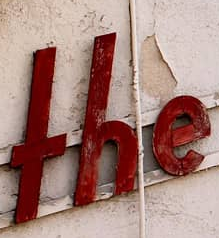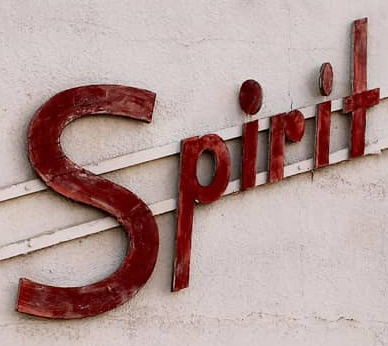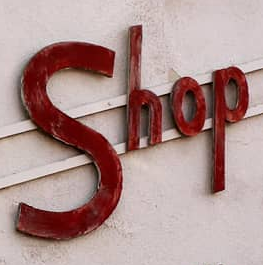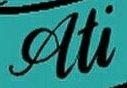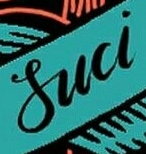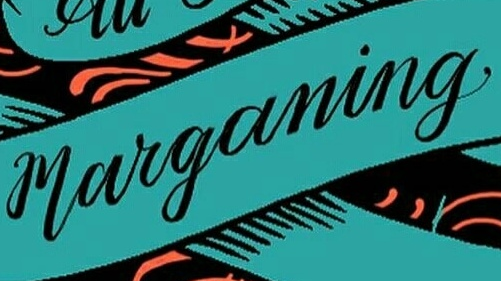What text is displayed in these images sequentially, separated by a semicolon? THE; Spirit; Shop; Ati; Suci; marganing 